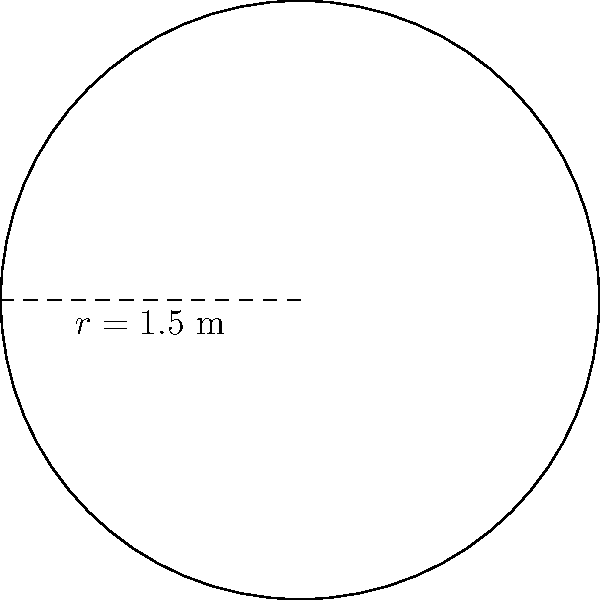A circular play mat is being considered for the daycare's toddler area. If the radius of the play mat is 1.5 meters, what is the area of the mat in square meters? Round your answer to two decimal places. To find the area of a circular play mat, we need to use the formula for the area of a circle:

$$ A = \pi r^2 $$

Where:
$A$ is the area of the circle
$\pi$ (pi) is approximately 3.14159
$r$ is the radius of the circle

Given:
The radius of the play mat is 1.5 meters.

Step 1: Substitute the given radius into the formula.
$$ A = \pi (1.5)^2 $$

Step 2: Calculate the square of the radius.
$$ A = \pi (2.25) $$

Step 3: Multiply by π.
$$ A = 3.14159 * 2.25 $$
$$ A = 7.068577... $$

Step 4: Round the result to two decimal places.
$$ A \approx 7.07 \text{ m}^2 $$

Therefore, the area of the circular play mat is approximately 7.07 square meters.
Answer: 7.07 m² 